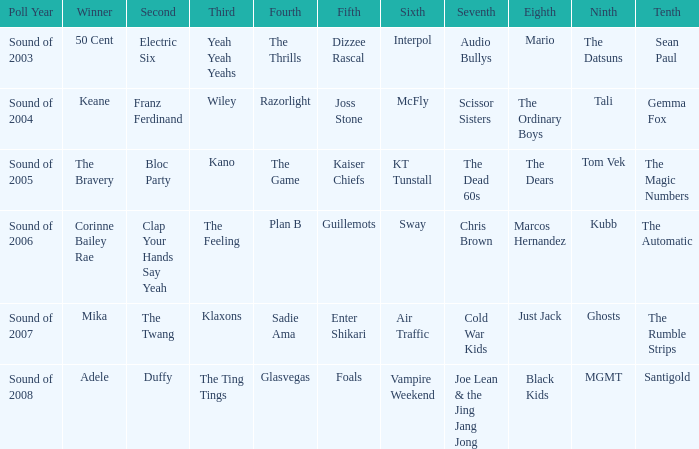When the 8th is Marcos Hernandez who was the 6th? Sway. 